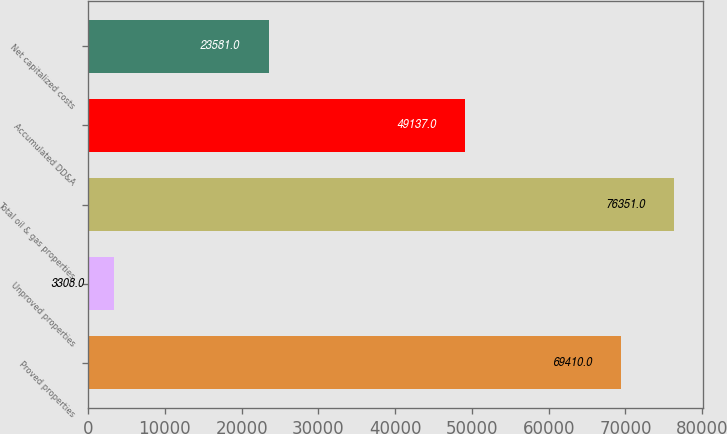<chart> <loc_0><loc_0><loc_500><loc_500><bar_chart><fcel>Proved properties<fcel>Unproved properties<fcel>Total oil & gas properties<fcel>Accumulated DD&A<fcel>Net capitalized costs<nl><fcel>69410<fcel>3308<fcel>76351<fcel>49137<fcel>23581<nl></chart> 